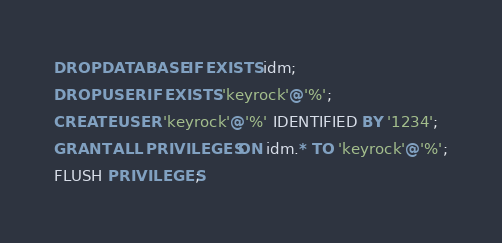<code> <loc_0><loc_0><loc_500><loc_500><_SQL_>DROP DATABASE IF EXISTS idm;
DROP USER IF EXISTS 'keyrock'@'%';
CREATE USER 'keyrock'@'%' IDENTIFIED BY '1234';
GRANT ALL PRIVILEGES ON idm.* TO 'keyrock'@'%';
FLUSH PRIVILEGES;
</code> 